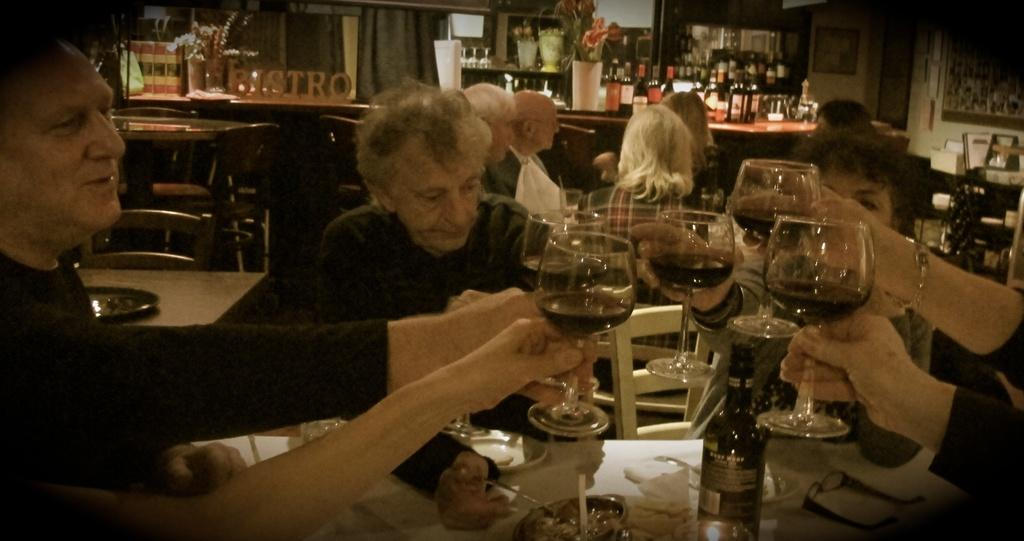What are the people in the image doing? The people in the image are sitting on chairs. What are the people holding in their hands? The people are holding wine glasses. What else can be seen in the image related to the activity? There are alcohol bottles in the image. What type of table is present in the image? There is a dining table in the image. Can you tell me how many bees are buzzing around the wine glasses in the image? There are no bees present in the image; it only features people sitting on chairs, holding wine glasses, and alcohol bottles on a dining table. 